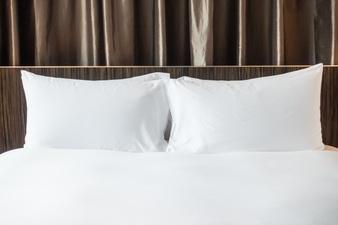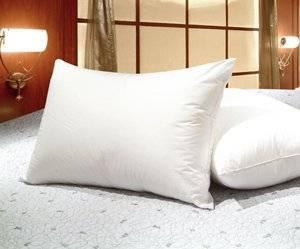The first image is the image on the left, the second image is the image on the right. Assess this claim about the two images: "One image shows a bed with all white bedding in front of a brown headboard and matching drape.". Correct or not? Answer yes or no. Yes. The first image is the image on the left, the second image is the image on the right. For the images displayed, is the sentence "there is white bedding on a bed with dark curtains behind the bed" factually correct? Answer yes or no. Yes. 